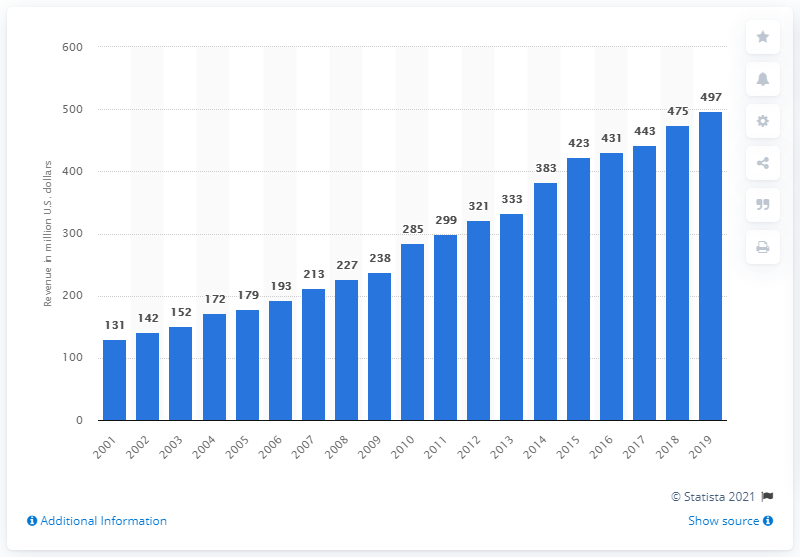Give some essential details in this illustration. The revenue of the New York Jets in 2019 was 497 million dollars. 